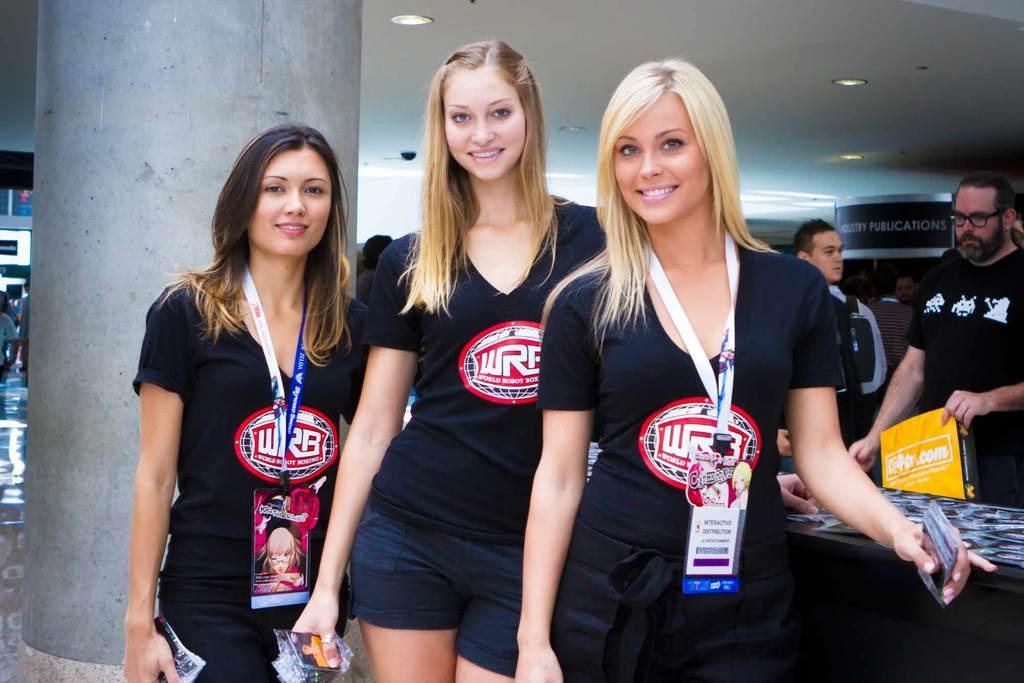Provide a one-sentence caption for the provided image. Three women pose for the camera and wear shirts for World Robot Boxing. 